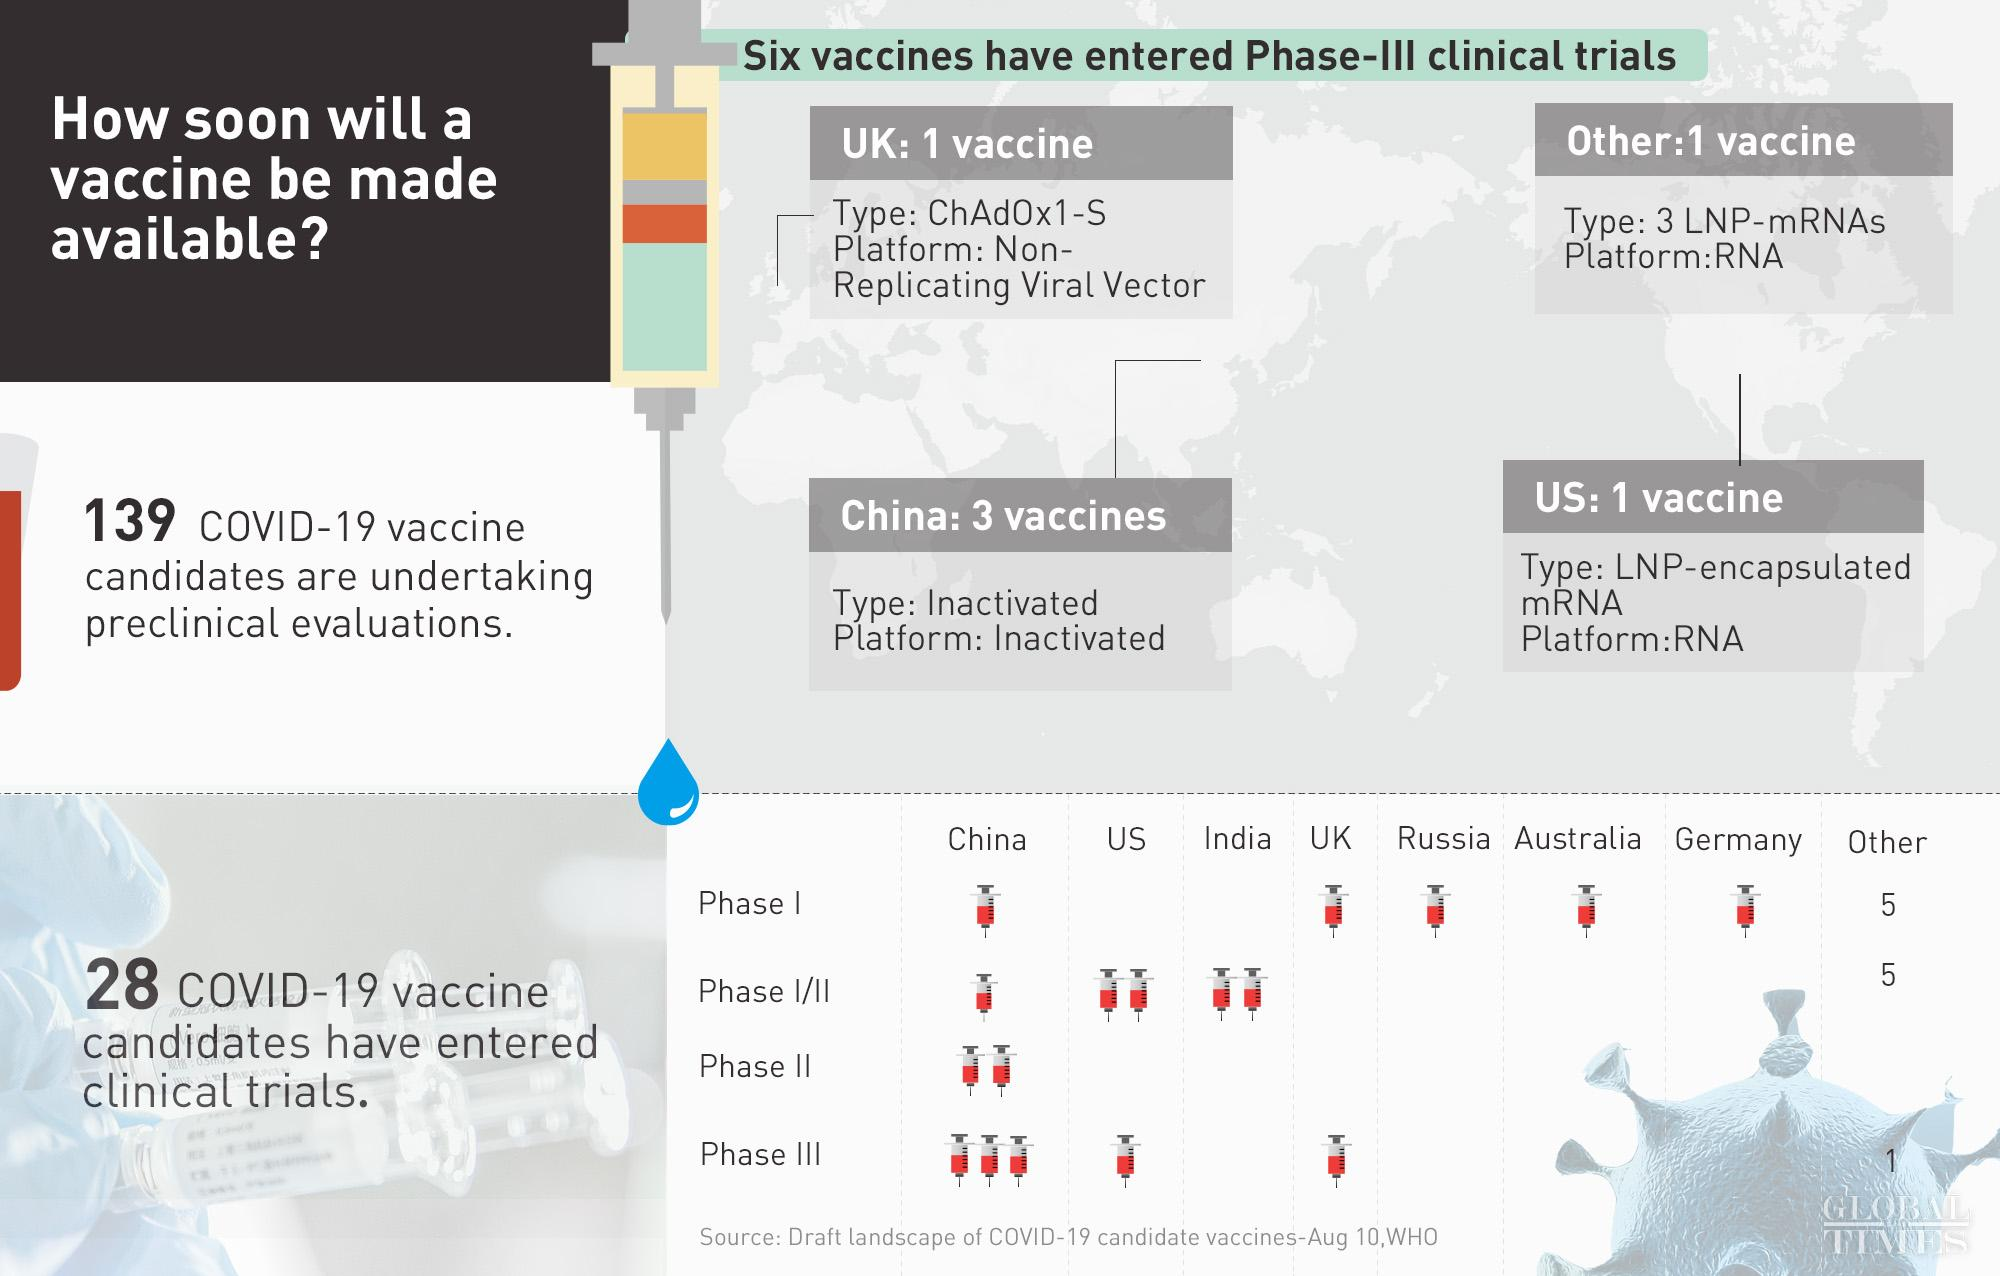Outline some significant characteristics in this image. The third phase includes six vaccines. In Russia, one vaccine candidate has entered clinical trial. The United States has initiated three vaccine candidates that have entered clinical trials. There are 10 vaccines in Phase I/II. Two vaccine candidates developed in India have commenced clinical trials. 